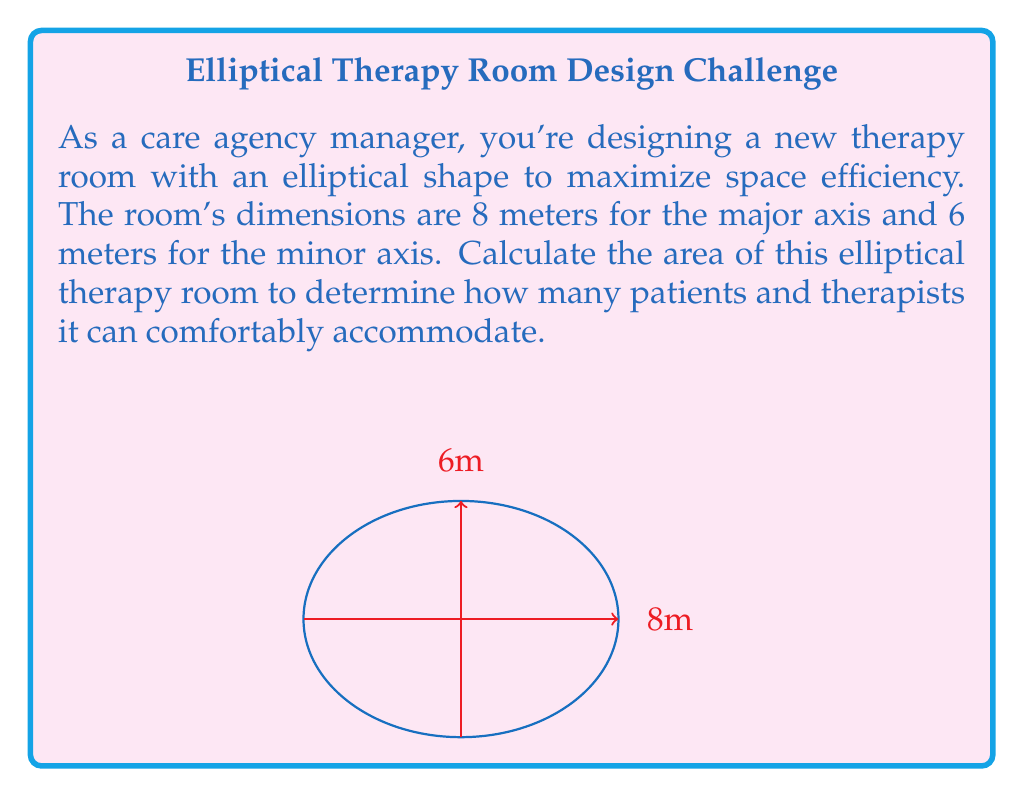Provide a solution to this math problem. To calculate the area of an ellipse, we use the formula:

$$A = \pi ab$$

Where:
$A$ = area of the ellipse
$a$ = length of the semi-major axis (half of the major axis)
$b$ = length of the semi-minor axis (half of the minor axis)

Given:
- Major axis = 8 meters
- Minor axis = 6 meters

Step 1: Calculate the semi-major and semi-minor axes
$a = 8 \div 2 = 4$ meters
$b = 6 \div 2 = 3$ meters

Step 2: Apply the formula
$$A = \pi ab$$
$$A = \pi(4)(3)$$
$$A = 12\pi$$

Step 3: Calculate the final area
$$A = 12\pi \approx 37.70 \text{ square meters}$$

Therefore, the area of the elliptical therapy room is approximately 37.70 square meters.
Answer: $37.70 \text{ m}^2$ 